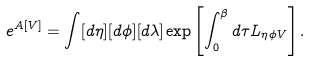<formula> <loc_0><loc_0><loc_500><loc_500>e ^ { A [ V ] } = \int [ d \eta ] [ d \phi ] [ d \lambda ] \exp \left [ \int ^ { \beta } _ { 0 } d \tau L _ { \eta \phi V } \right ] .</formula> 